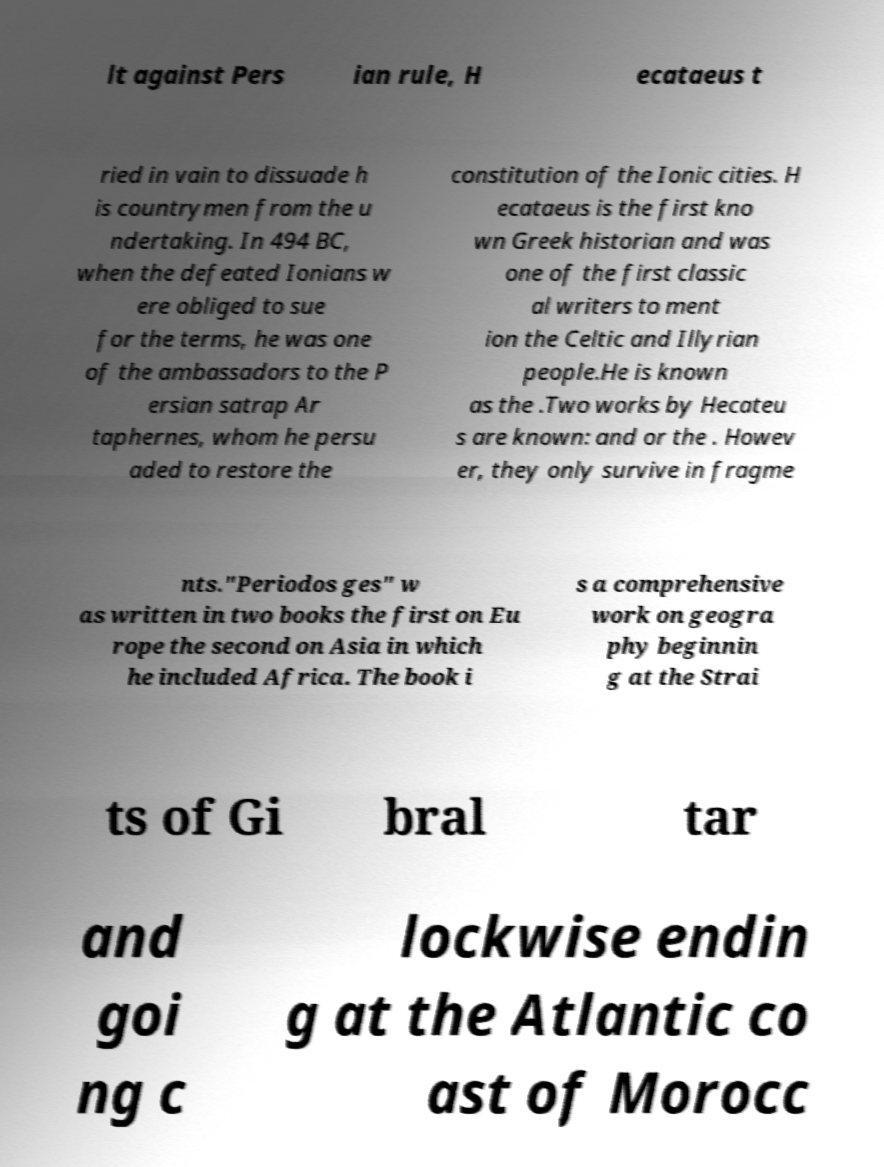Could you extract and type out the text from this image? lt against Pers ian rule, H ecataeus t ried in vain to dissuade h is countrymen from the u ndertaking. In 494 BC, when the defeated Ionians w ere obliged to sue for the terms, he was one of the ambassadors to the P ersian satrap Ar taphernes, whom he persu aded to restore the constitution of the Ionic cities. H ecataeus is the first kno wn Greek historian and was one of the first classic al writers to ment ion the Celtic and Illyrian people.He is known as the .Two works by Hecateu s are known: and or the . Howev er, they only survive in fragme nts."Periodos ges" w as written in two books the first on Eu rope the second on Asia in which he included Africa. The book i s a comprehensive work on geogra phy beginnin g at the Strai ts of Gi bral tar and goi ng c lockwise endin g at the Atlantic co ast of Morocc 